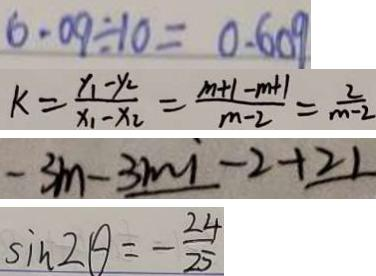Convert formula to latex. <formula><loc_0><loc_0><loc_500><loc_500>6 . 0 9 \div 1 0 = 0 . 6 0 9 
 k = \frac { x _ { 1 } - y _ { 2 } } { x _ { 1 } - x _ { 2 } } = \frac { m + 1 - m + 1 } { m - 2 } = \frac { 2 } { m - 2 } 
 - 3 m - 3 m i - 2 + 2 1 
 \sin 2 \theta = - \frac { 2 4 } { 2 5 }</formula> 